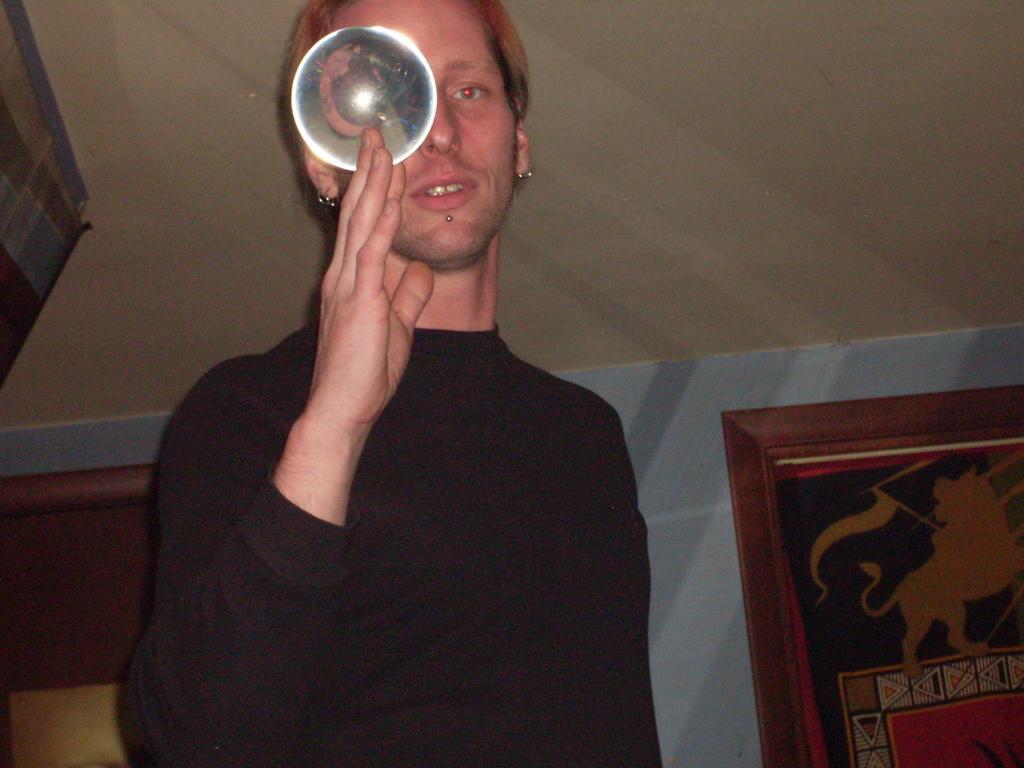Describe this image in one or two sentences. In this image we can see a man standing and holding a disc in his hand. In the background there are wall hangings attached to the wall. 